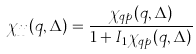Convert formula to latex. <formula><loc_0><loc_0><loc_500><loc_500>\chi _ { j j } ( q , \Delta ) = \frac { \chi _ { q p } ( q , \Delta ) } { 1 + I _ { 1 } \chi _ { q p } ( q , \Delta ) }</formula> 